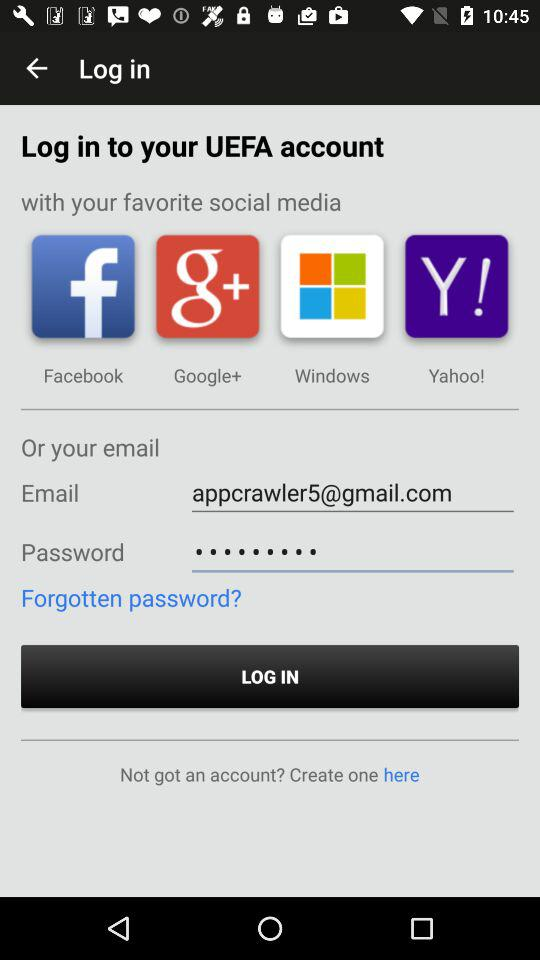Which application can be used to log in? The applications are "Facebook", "Google+", "Windows" and "Yahoo!". 